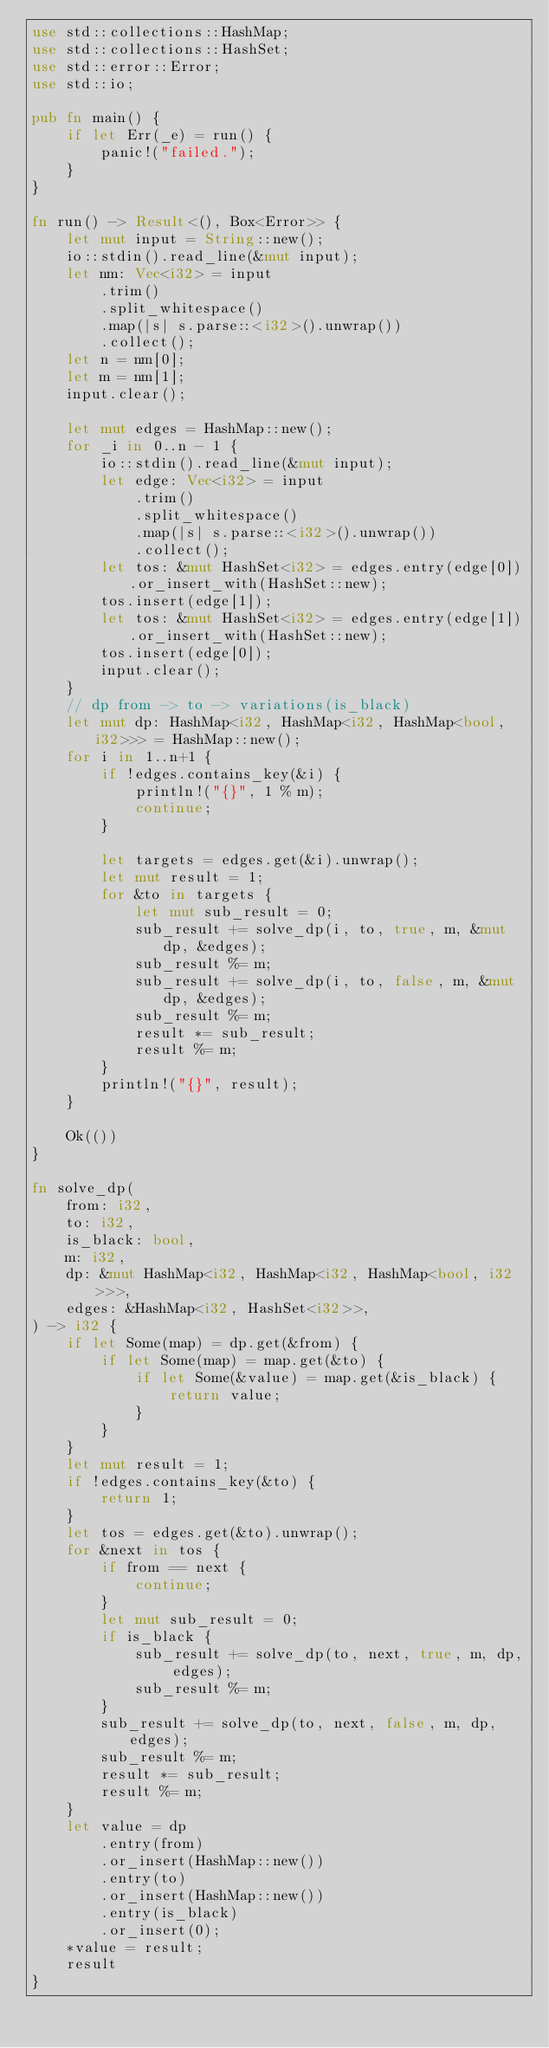Convert code to text. <code><loc_0><loc_0><loc_500><loc_500><_Rust_>use std::collections::HashMap;
use std::collections::HashSet;
use std::error::Error;
use std::io;

pub fn main() {
    if let Err(_e) = run() {
        panic!("failed.");
    }
}

fn run() -> Result<(), Box<Error>> {
    let mut input = String::new();
    io::stdin().read_line(&mut input);
    let nm: Vec<i32> = input
        .trim()
        .split_whitespace()
        .map(|s| s.parse::<i32>().unwrap())
        .collect();
    let n = nm[0];
    let m = nm[1];
    input.clear();

    let mut edges = HashMap::new();
    for _i in 0..n - 1 {
        io::stdin().read_line(&mut input);
        let edge: Vec<i32> = input
            .trim()
            .split_whitespace()
            .map(|s| s.parse::<i32>().unwrap())
            .collect();
        let tos: &mut HashSet<i32> = edges.entry(edge[0]).or_insert_with(HashSet::new);
        tos.insert(edge[1]);
        let tos: &mut HashSet<i32> = edges.entry(edge[1]).or_insert_with(HashSet::new);
        tos.insert(edge[0]);
        input.clear();
    }
    // dp from -> to -> variations(is_black)
    let mut dp: HashMap<i32, HashMap<i32, HashMap<bool, i32>>> = HashMap::new();
    for i in 1..n+1 {
        if !edges.contains_key(&i) {
            println!("{}", 1 % m);
            continue;
        }

        let targets = edges.get(&i).unwrap();
        let mut result = 1;
        for &to in targets {
            let mut sub_result = 0;
            sub_result += solve_dp(i, to, true, m, &mut dp, &edges);
            sub_result %= m;
            sub_result += solve_dp(i, to, false, m, &mut dp, &edges);
            sub_result %= m;
            result *= sub_result;
            result %= m;
        }
        println!("{}", result);
    }

    Ok(())
}

fn solve_dp(
    from: i32,
    to: i32,
    is_black: bool,
    m: i32,
    dp: &mut HashMap<i32, HashMap<i32, HashMap<bool, i32>>>,
    edges: &HashMap<i32, HashSet<i32>>,
) -> i32 {
    if let Some(map) = dp.get(&from) {
        if let Some(map) = map.get(&to) {
            if let Some(&value) = map.get(&is_black) {
                return value;
            }
        }
    }
    let mut result = 1;
    if !edges.contains_key(&to) {
        return 1;
    }
    let tos = edges.get(&to).unwrap();
    for &next in tos {
        if from == next {
            continue;
        }
        let mut sub_result = 0;
        if is_black {
            sub_result += solve_dp(to, next, true, m, dp, edges);
            sub_result %= m;
        }
        sub_result += solve_dp(to, next, false, m, dp, edges);
        sub_result %= m;
        result *= sub_result;
        result %= m;
    }
    let value = dp
        .entry(from)
        .or_insert(HashMap::new())
        .entry(to)
        .or_insert(HashMap::new())
        .entry(is_black)
        .or_insert(0);
    *value = result;
    result
}
</code> 